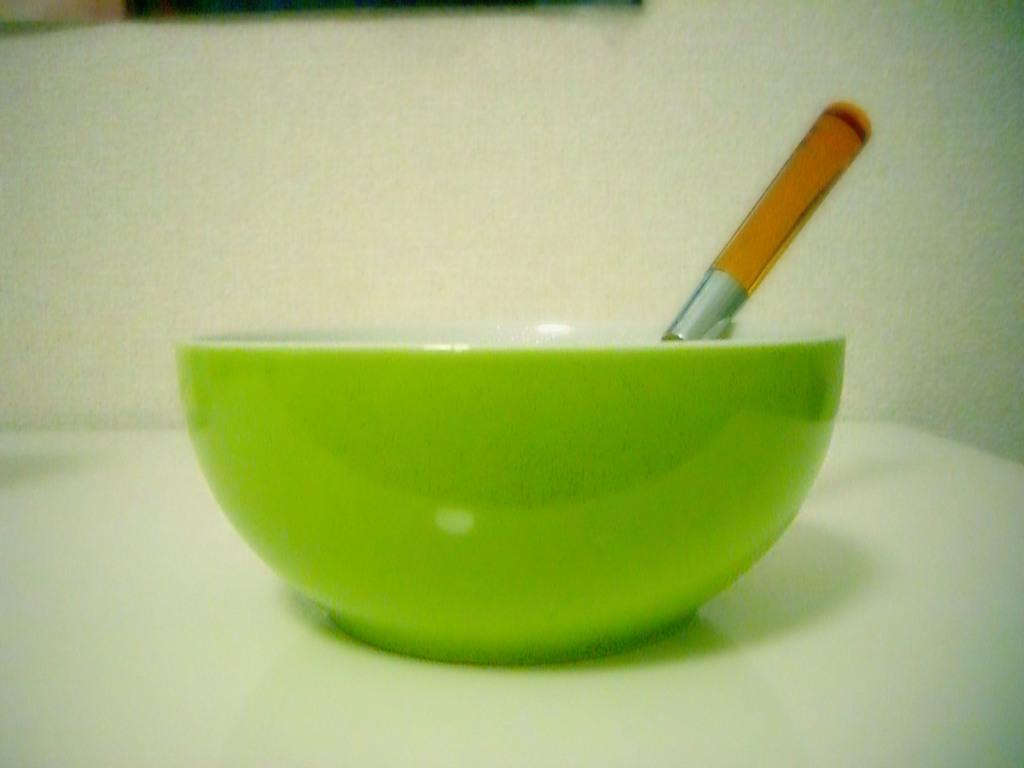What is located on the table in the image? There is a bowl and a spoon placed on the table in the image. What is the purpose of the spoon in the image? The spoon is likely used for eating or serving the contents of the bowl. What can be seen in the background of the image? There is a well in the background of the image. How many pizzas are being shared by the partners in the image? There are no partners or pizzas present in the image. What type of blood is visible on the well in the image? There is no blood visible in the image, only a well in the background. 